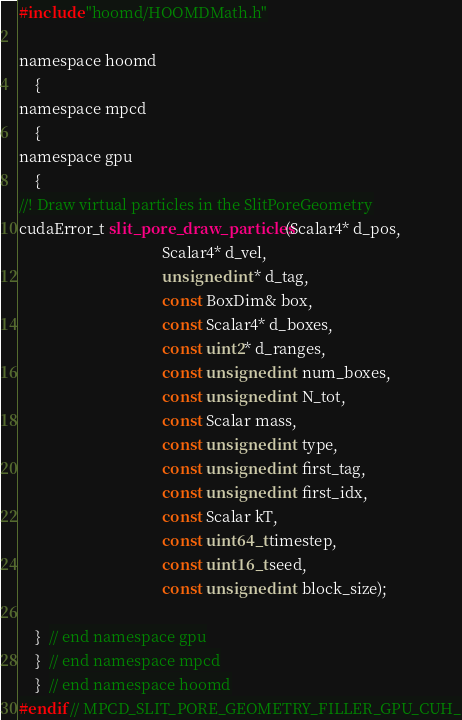Convert code to text. <code><loc_0><loc_0><loc_500><loc_500><_Cuda_>#include "hoomd/HOOMDMath.h"

namespace hoomd
    {
namespace mpcd
    {
namespace gpu
    {
//! Draw virtual particles in the SlitPoreGeometry
cudaError_t slit_pore_draw_particles(Scalar4* d_pos,
                                     Scalar4* d_vel,
                                     unsigned int* d_tag,
                                     const BoxDim& box,
                                     const Scalar4* d_boxes,
                                     const uint2* d_ranges,
                                     const unsigned int num_boxes,
                                     const unsigned int N_tot,
                                     const Scalar mass,
                                     const unsigned int type,
                                     const unsigned int first_tag,
                                     const unsigned int first_idx,
                                     const Scalar kT,
                                     const uint64_t timestep,
                                     const uint16_t seed,
                                     const unsigned int block_size);

    }  // end namespace gpu
    }  // end namespace mpcd
    }  // end namespace hoomd
#endif // MPCD_SLIT_PORE_GEOMETRY_FILLER_GPU_CUH_
</code> 